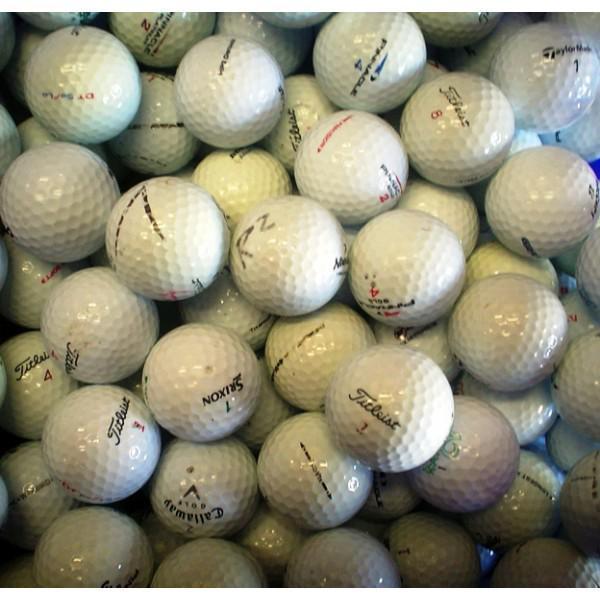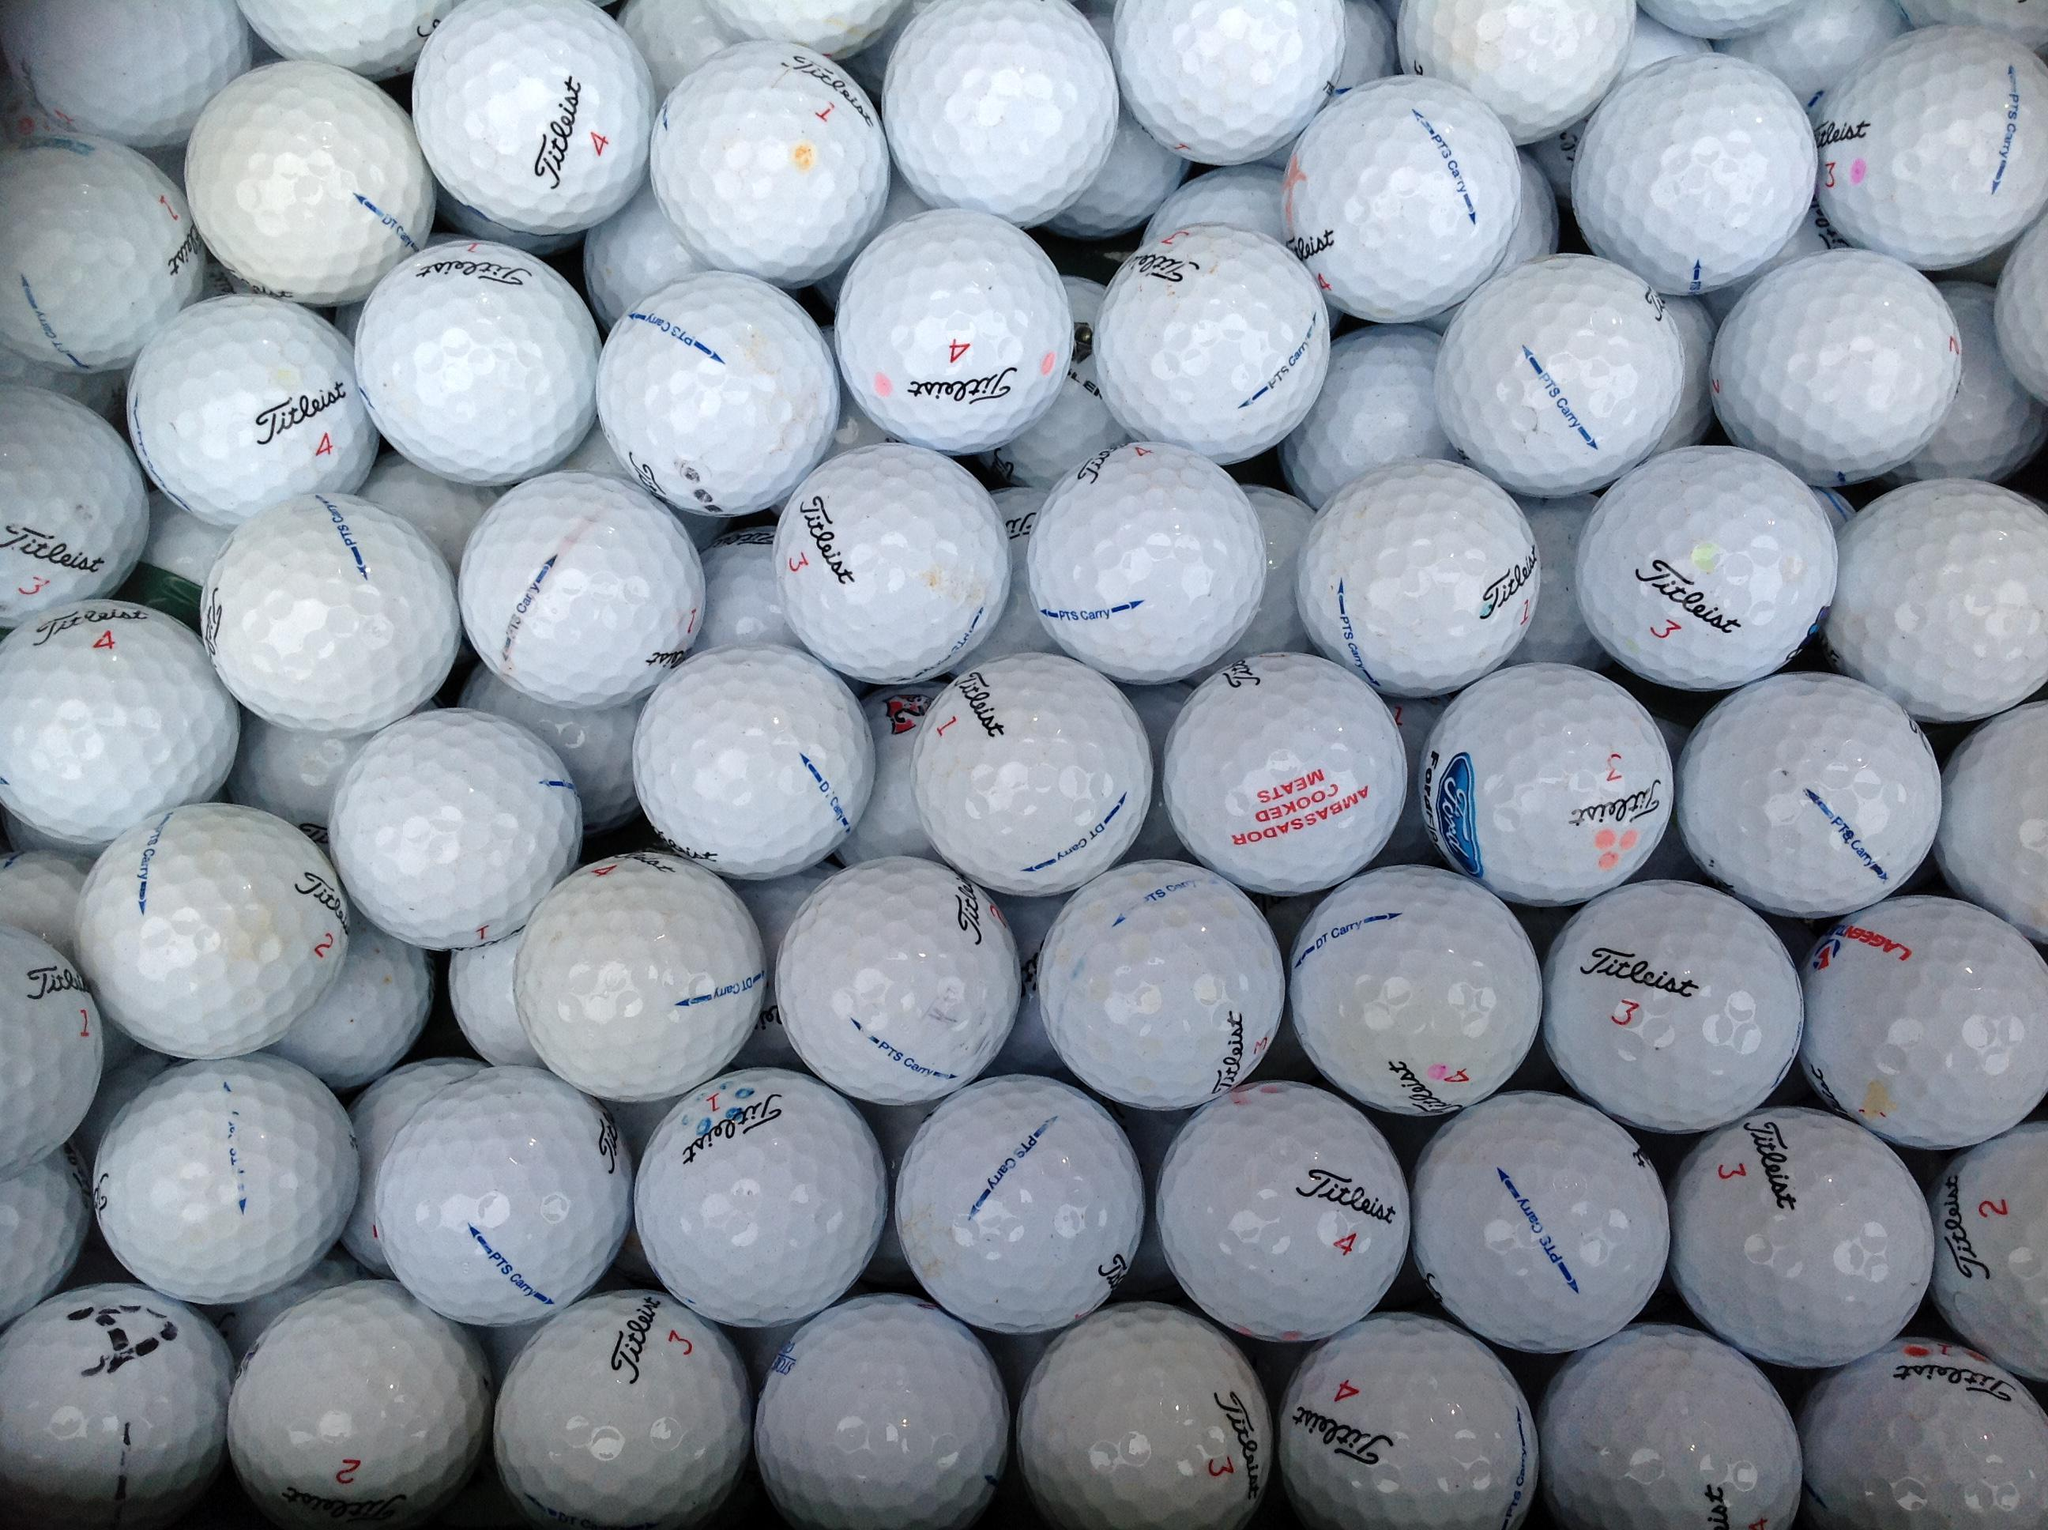The first image is the image on the left, the second image is the image on the right. Examine the images to the left and right. Is the description "Some of the balls are sitting in tubs." accurate? Answer yes or no. No. The first image is the image on the left, the second image is the image on the right. For the images shown, is this caption "An image shows many golf balls piled into a squarish tub container." true? Answer yes or no. No. 